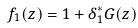<formula> <loc_0><loc_0><loc_500><loc_500>f _ { 1 } ( z ) = 1 + \delta _ { 1 } ^ { * } G ( z )</formula> 